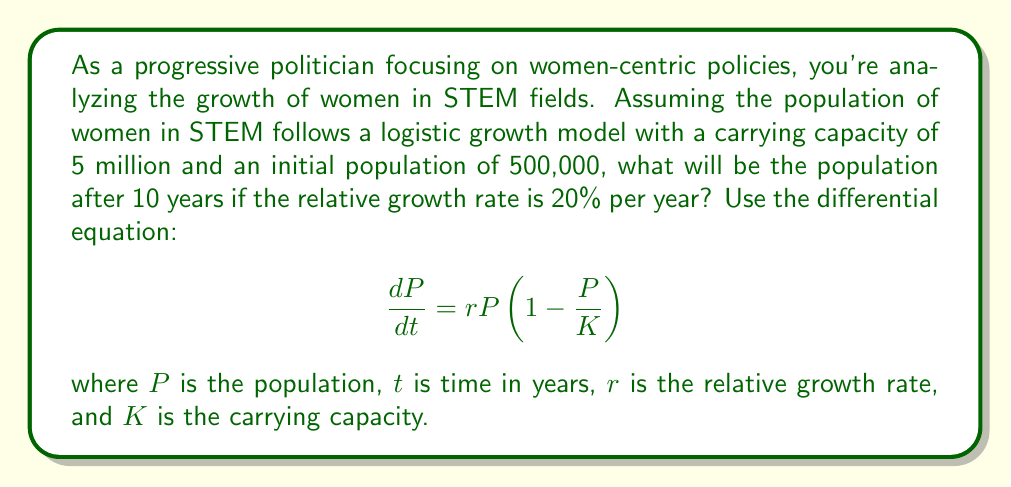Help me with this question. To solve this problem, we need to use the logistic growth model and its solution. The logistic differential equation is:

$$\frac{dP}{dt} = rP(1-\frac{P}{K})$$

The solution to this differential equation is:

$$P(t) = \frac{K}{1 + (\frac{K}{P_0} - 1)e^{-rt}}$$

Where:
$K$ = carrying capacity = 5,000,000
$P_0$ = initial population = 500,000
$r$ = relative growth rate = 0.20 (20% per year)
$t$ = time = 10 years

Let's substitute these values into the equation:

$$P(10) = \frac{5,000,000}{1 + (\frac{5,000,000}{500,000} - 1)e^{-0.20 \times 10}}$$

$$= \frac{5,000,000}{1 + (10 - 1)e^{-2}}$$

$$= \frac{5,000,000}{1 + 9e^{-2}}$$

Now, let's calculate:

$e^{-2} \approx 0.1353$

$$P(10) = \frac{5,000,000}{1 + 9 \times 0.1353}$$

$$= \frac{5,000,000}{2.2177}$$

$$\approx 2,254,587$$

Therefore, after 10 years, the population of women in STEM fields will be approximately 2,254,587.
Answer: 2,254,587 women in STEM fields after 10 years 